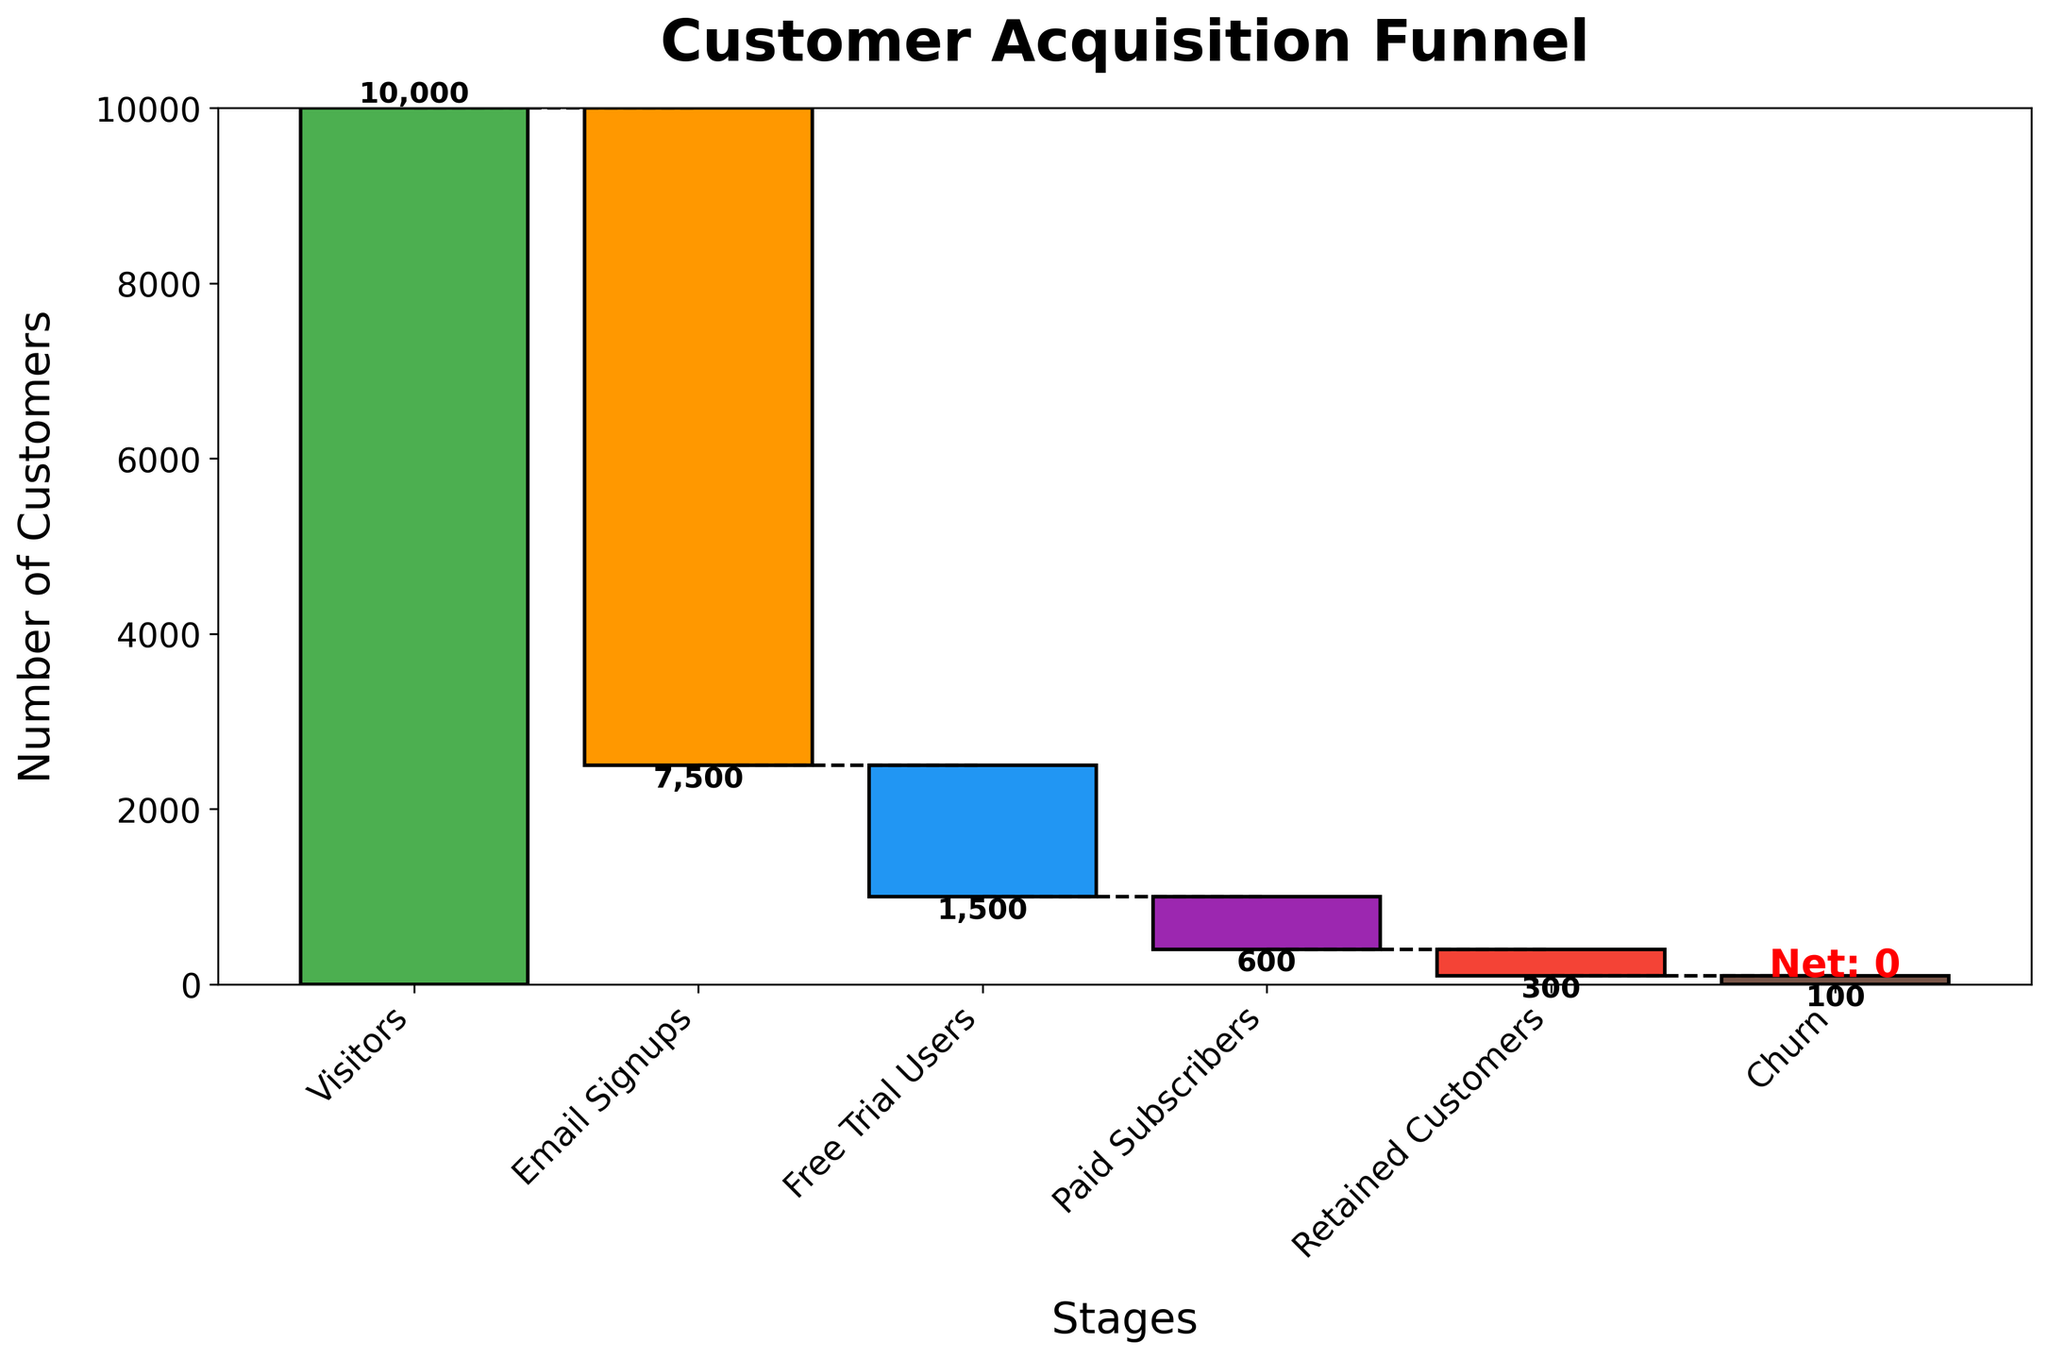What is the title of the chart? The title of the chart is usually displayed at the top of the figure in a larger and bolder font size to capture the viewer's attention. In this case, it is "Customer Acquisition Funnel."
Answer: Customer Acquisition Funnel How many stages are shown in the Customer Acquisition Funnel? By counting the stage labels on the x-axis, we can see there are six distinct stages shown in the funnel.
Answer: Six What is the initial number of visitors in the funnel? The initial number of visitors can be found at the first stage of the funnel, which is "Visitors."
Answer: 10,000 How many free trial users were there? The number of free trial users is given directly in the pipeline under the stage labeled "Free Trial Users."
Answer: 1,500 Which stage has the most significant drop in customer numbers? By looking at the length of the bars and the values displayed, the most significant drop occurs at the "Email Signups" stage, which decreases by 7,500.
Answer: Email Signups What is the net result of retained customers in the funnel? The final value in the funnel is displayed under the stage "Net result". It shows the total number of retained customers after accounting for the churn.
Answer: 300 How many customers end up as paid subscribers? The number of customers at the "Paid Subscribers" stage can be directly read off from the figure.
Answer: 600 How does the number of retained customers compare to the number of free trial users? By comparing the values at the "Free Trial Users" and "Retained Customers" stages, we see that the retained customers (300) are significantly fewer than the free trial users (1,500).
Answer: Fewer by 1,200 What is the total number of customers lost between visitors and email signups? To find the total number of customers lost between "Visitors" and "Email Signups", we subtract the number of email signups (7,500) from the number of visitors (10,000).
Answer: 2,500 What line style is used to connect the stages? The lines connecting the stages are described as black dashed lines in the plot details. These lines help the viewer follow the cumulative values across stages.
Answer: Black dashed lines 